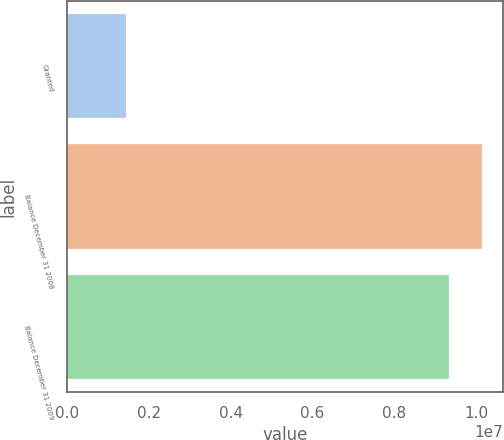Convert chart to OTSL. <chart><loc_0><loc_0><loc_500><loc_500><bar_chart><fcel>Granted<fcel>Balance December 31 2008<fcel>Balance December 31 2009<nl><fcel>1.44242e+06<fcel>1.01515e+07<fcel>9.32941e+06<nl></chart> 